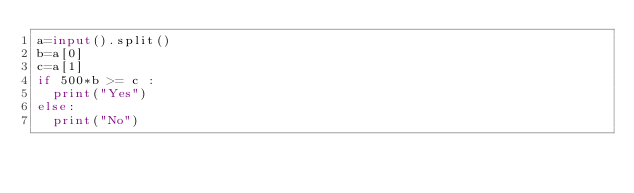<code> <loc_0><loc_0><loc_500><loc_500><_Python_>a=input().split()
b=a[0]
c=a[1]
if 500*b >= c :
  print("Yes")
else:
  print("No")</code> 